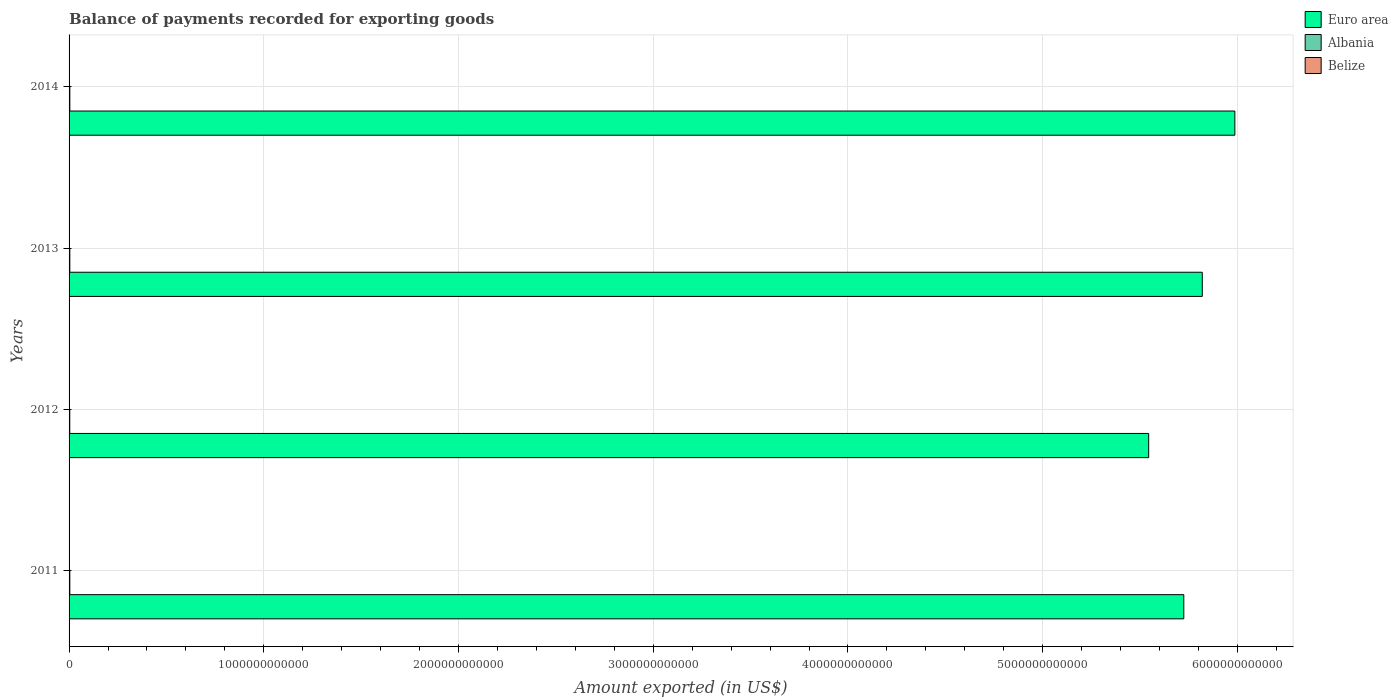How many different coloured bars are there?
Your response must be concise. 3. How many groups of bars are there?
Provide a succinct answer. 4. Are the number of bars per tick equal to the number of legend labels?
Give a very brief answer. Yes. Are the number of bars on each tick of the Y-axis equal?
Keep it short and to the point. Yes. How many bars are there on the 4th tick from the top?
Your response must be concise. 3. What is the label of the 1st group of bars from the top?
Your answer should be very brief. 2014. In how many cases, is the number of bars for a given year not equal to the number of legend labels?
Give a very brief answer. 0. What is the amount exported in Albania in 2014?
Ensure brevity in your answer.  3.92e+09. Across all years, what is the maximum amount exported in Euro area?
Provide a short and direct response. 5.99e+12. Across all years, what is the minimum amount exported in Albania?
Your response must be concise. 3.56e+09. What is the total amount exported in Euro area in the graph?
Your response must be concise. 2.31e+13. What is the difference between the amount exported in Albania in 2012 and that in 2013?
Your response must be concise. -2.87e+08. What is the difference between the amount exported in Albania in 2011 and the amount exported in Euro area in 2013?
Give a very brief answer. -5.82e+12. What is the average amount exported in Albania per year?
Offer a terse response. 3.78e+09. In the year 2012, what is the difference between the amount exported in Belize and amount exported in Euro area?
Your answer should be very brief. -5.54e+12. In how many years, is the amount exported in Albania greater than 1200000000000 US$?
Keep it short and to the point. 0. What is the ratio of the amount exported in Euro area in 2012 to that in 2013?
Ensure brevity in your answer.  0.95. Is the difference between the amount exported in Belize in 2011 and 2014 greater than the difference between the amount exported in Euro area in 2011 and 2014?
Ensure brevity in your answer.  Yes. What is the difference between the highest and the second highest amount exported in Euro area?
Your answer should be very brief. 1.67e+11. What is the difference between the highest and the lowest amount exported in Euro area?
Ensure brevity in your answer.  4.43e+11. In how many years, is the amount exported in Belize greater than the average amount exported in Belize taken over all years?
Provide a succinct answer. 3. What does the 2nd bar from the top in 2012 represents?
Provide a short and direct response. Albania. What does the 2nd bar from the bottom in 2012 represents?
Ensure brevity in your answer.  Albania. Are all the bars in the graph horizontal?
Make the answer very short. Yes. What is the difference between two consecutive major ticks on the X-axis?
Offer a terse response. 1.00e+12. Are the values on the major ticks of X-axis written in scientific E-notation?
Offer a very short reply. No. Does the graph contain any zero values?
Your response must be concise. No. Does the graph contain grids?
Offer a terse response. Yes. Where does the legend appear in the graph?
Your answer should be compact. Top right. How many legend labels are there?
Offer a very short reply. 3. How are the legend labels stacked?
Offer a very short reply. Vertical. What is the title of the graph?
Your answer should be very brief. Balance of payments recorded for exporting goods. Does "Channel Islands" appear as one of the legend labels in the graph?
Your answer should be very brief. No. What is the label or title of the X-axis?
Your answer should be very brief. Amount exported (in US$). What is the Amount exported (in US$) of Euro area in 2011?
Give a very brief answer. 5.72e+12. What is the Amount exported (in US$) of Albania in 2011?
Make the answer very short. 3.78e+09. What is the Amount exported (in US$) of Belize in 2011?
Give a very brief answer. 9.44e+08. What is the Amount exported (in US$) in Euro area in 2012?
Provide a succinct answer. 5.54e+12. What is the Amount exported (in US$) in Albania in 2012?
Give a very brief answer. 3.56e+09. What is the Amount exported (in US$) of Belize in 2012?
Offer a terse response. 1.03e+09. What is the Amount exported (in US$) of Euro area in 2013?
Your answer should be very brief. 5.82e+12. What is the Amount exported (in US$) of Albania in 2013?
Your answer should be compact. 3.84e+09. What is the Amount exported (in US$) in Belize in 2013?
Your response must be concise. 1.06e+09. What is the Amount exported (in US$) of Euro area in 2014?
Your response must be concise. 5.99e+12. What is the Amount exported (in US$) in Albania in 2014?
Provide a succinct answer. 3.92e+09. What is the Amount exported (in US$) in Belize in 2014?
Ensure brevity in your answer.  1.08e+09. Across all years, what is the maximum Amount exported (in US$) in Euro area?
Your response must be concise. 5.99e+12. Across all years, what is the maximum Amount exported (in US$) in Albania?
Give a very brief answer. 3.92e+09. Across all years, what is the maximum Amount exported (in US$) of Belize?
Offer a very short reply. 1.08e+09. Across all years, what is the minimum Amount exported (in US$) of Euro area?
Offer a very short reply. 5.54e+12. Across all years, what is the minimum Amount exported (in US$) of Albania?
Your response must be concise. 3.56e+09. Across all years, what is the minimum Amount exported (in US$) in Belize?
Provide a succinct answer. 9.44e+08. What is the total Amount exported (in US$) of Euro area in the graph?
Ensure brevity in your answer.  2.31e+13. What is the total Amount exported (in US$) of Albania in the graph?
Provide a short and direct response. 1.51e+1. What is the total Amount exported (in US$) of Belize in the graph?
Offer a very short reply. 4.12e+09. What is the difference between the Amount exported (in US$) in Euro area in 2011 and that in 2012?
Ensure brevity in your answer.  1.80e+11. What is the difference between the Amount exported (in US$) in Albania in 2011 and that in 2012?
Offer a very short reply. 2.19e+08. What is the difference between the Amount exported (in US$) in Belize in 2011 and that in 2012?
Your answer should be very brief. -9.06e+07. What is the difference between the Amount exported (in US$) of Euro area in 2011 and that in 2013?
Give a very brief answer. -9.49e+1. What is the difference between the Amount exported (in US$) in Albania in 2011 and that in 2013?
Ensure brevity in your answer.  -6.77e+07. What is the difference between the Amount exported (in US$) in Belize in 2011 and that in 2013?
Provide a short and direct response. -1.12e+08. What is the difference between the Amount exported (in US$) in Euro area in 2011 and that in 2014?
Keep it short and to the point. -2.62e+11. What is the difference between the Amount exported (in US$) of Albania in 2011 and that in 2014?
Your answer should be compact. -1.48e+08. What is the difference between the Amount exported (in US$) in Belize in 2011 and that in 2014?
Provide a short and direct response. -1.39e+08. What is the difference between the Amount exported (in US$) in Euro area in 2012 and that in 2013?
Offer a terse response. -2.75e+11. What is the difference between the Amount exported (in US$) of Albania in 2012 and that in 2013?
Ensure brevity in your answer.  -2.87e+08. What is the difference between the Amount exported (in US$) in Belize in 2012 and that in 2013?
Ensure brevity in your answer.  -2.17e+07. What is the difference between the Amount exported (in US$) of Euro area in 2012 and that in 2014?
Your answer should be very brief. -4.43e+11. What is the difference between the Amount exported (in US$) of Albania in 2012 and that in 2014?
Make the answer very short. -3.67e+08. What is the difference between the Amount exported (in US$) in Belize in 2012 and that in 2014?
Ensure brevity in your answer.  -4.86e+07. What is the difference between the Amount exported (in US$) in Euro area in 2013 and that in 2014?
Provide a succinct answer. -1.67e+11. What is the difference between the Amount exported (in US$) of Albania in 2013 and that in 2014?
Give a very brief answer. -8.00e+07. What is the difference between the Amount exported (in US$) of Belize in 2013 and that in 2014?
Your answer should be very brief. -2.69e+07. What is the difference between the Amount exported (in US$) in Euro area in 2011 and the Amount exported (in US$) in Albania in 2012?
Your answer should be compact. 5.72e+12. What is the difference between the Amount exported (in US$) in Euro area in 2011 and the Amount exported (in US$) in Belize in 2012?
Provide a short and direct response. 5.72e+12. What is the difference between the Amount exported (in US$) in Albania in 2011 and the Amount exported (in US$) in Belize in 2012?
Your response must be concise. 2.74e+09. What is the difference between the Amount exported (in US$) of Euro area in 2011 and the Amount exported (in US$) of Albania in 2013?
Your response must be concise. 5.72e+12. What is the difference between the Amount exported (in US$) in Euro area in 2011 and the Amount exported (in US$) in Belize in 2013?
Keep it short and to the point. 5.72e+12. What is the difference between the Amount exported (in US$) of Albania in 2011 and the Amount exported (in US$) of Belize in 2013?
Your answer should be very brief. 2.72e+09. What is the difference between the Amount exported (in US$) in Euro area in 2011 and the Amount exported (in US$) in Albania in 2014?
Offer a terse response. 5.72e+12. What is the difference between the Amount exported (in US$) of Euro area in 2011 and the Amount exported (in US$) of Belize in 2014?
Your response must be concise. 5.72e+12. What is the difference between the Amount exported (in US$) in Albania in 2011 and the Amount exported (in US$) in Belize in 2014?
Offer a terse response. 2.69e+09. What is the difference between the Amount exported (in US$) of Euro area in 2012 and the Amount exported (in US$) of Albania in 2013?
Ensure brevity in your answer.  5.54e+12. What is the difference between the Amount exported (in US$) of Euro area in 2012 and the Amount exported (in US$) of Belize in 2013?
Your answer should be very brief. 5.54e+12. What is the difference between the Amount exported (in US$) in Albania in 2012 and the Amount exported (in US$) in Belize in 2013?
Your response must be concise. 2.50e+09. What is the difference between the Amount exported (in US$) in Euro area in 2012 and the Amount exported (in US$) in Albania in 2014?
Give a very brief answer. 5.54e+12. What is the difference between the Amount exported (in US$) of Euro area in 2012 and the Amount exported (in US$) of Belize in 2014?
Make the answer very short. 5.54e+12. What is the difference between the Amount exported (in US$) of Albania in 2012 and the Amount exported (in US$) of Belize in 2014?
Your answer should be very brief. 2.47e+09. What is the difference between the Amount exported (in US$) of Euro area in 2013 and the Amount exported (in US$) of Albania in 2014?
Provide a short and direct response. 5.82e+12. What is the difference between the Amount exported (in US$) of Euro area in 2013 and the Amount exported (in US$) of Belize in 2014?
Provide a short and direct response. 5.82e+12. What is the difference between the Amount exported (in US$) in Albania in 2013 and the Amount exported (in US$) in Belize in 2014?
Provide a succinct answer. 2.76e+09. What is the average Amount exported (in US$) of Euro area per year?
Your response must be concise. 5.77e+12. What is the average Amount exported (in US$) in Albania per year?
Make the answer very short. 3.78e+09. What is the average Amount exported (in US$) in Belize per year?
Your answer should be very brief. 1.03e+09. In the year 2011, what is the difference between the Amount exported (in US$) in Euro area and Amount exported (in US$) in Albania?
Your answer should be very brief. 5.72e+12. In the year 2011, what is the difference between the Amount exported (in US$) of Euro area and Amount exported (in US$) of Belize?
Your response must be concise. 5.72e+12. In the year 2011, what is the difference between the Amount exported (in US$) in Albania and Amount exported (in US$) in Belize?
Keep it short and to the point. 2.83e+09. In the year 2012, what is the difference between the Amount exported (in US$) in Euro area and Amount exported (in US$) in Albania?
Your answer should be very brief. 5.54e+12. In the year 2012, what is the difference between the Amount exported (in US$) of Euro area and Amount exported (in US$) of Belize?
Your answer should be very brief. 5.54e+12. In the year 2012, what is the difference between the Amount exported (in US$) in Albania and Amount exported (in US$) in Belize?
Your answer should be compact. 2.52e+09. In the year 2013, what is the difference between the Amount exported (in US$) of Euro area and Amount exported (in US$) of Albania?
Your response must be concise. 5.82e+12. In the year 2013, what is the difference between the Amount exported (in US$) in Euro area and Amount exported (in US$) in Belize?
Give a very brief answer. 5.82e+12. In the year 2013, what is the difference between the Amount exported (in US$) in Albania and Amount exported (in US$) in Belize?
Ensure brevity in your answer.  2.79e+09. In the year 2014, what is the difference between the Amount exported (in US$) in Euro area and Amount exported (in US$) in Albania?
Ensure brevity in your answer.  5.98e+12. In the year 2014, what is the difference between the Amount exported (in US$) of Euro area and Amount exported (in US$) of Belize?
Your response must be concise. 5.99e+12. In the year 2014, what is the difference between the Amount exported (in US$) of Albania and Amount exported (in US$) of Belize?
Ensure brevity in your answer.  2.84e+09. What is the ratio of the Amount exported (in US$) in Euro area in 2011 to that in 2012?
Keep it short and to the point. 1.03. What is the ratio of the Amount exported (in US$) of Albania in 2011 to that in 2012?
Ensure brevity in your answer.  1.06. What is the ratio of the Amount exported (in US$) of Belize in 2011 to that in 2012?
Make the answer very short. 0.91. What is the ratio of the Amount exported (in US$) in Euro area in 2011 to that in 2013?
Provide a succinct answer. 0.98. What is the ratio of the Amount exported (in US$) of Albania in 2011 to that in 2013?
Give a very brief answer. 0.98. What is the ratio of the Amount exported (in US$) of Belize in 2011 to that in 2013?
Provide a succinct answer. 0.89. What is the ratio of the Amount exported (in US$) of Euro area in 2011 to that in 2014?
Give a very brief answer. 0.96. What is the ratio of the Amount exported (in US$) of Albania in 2011 to that in 2014?
Keep it short and to the point. 0.96. What is the ratio of the Amount exported (in US$) of Belize in 2011 to that in 2014?
Provide a succinct answer. 0.87. What is the ratio of the Amount exported (in US$) of Euro area in 2012 to that in 2013?
Ensure brevity in your answer.  0.95. What is the ratio of the Amount exported (in US$) in Albania in 2012 to that in 2013?
Provide a short and direct response. 0.93. What is the ratio of the Amount exported (in US$) of Belize in 2012 to that in 2013?
Provide a short and direct response. 0.98. What is the ratio of the Amount exported (in US$) of Euro area in 2012 to that in 2014?
Your response must be concise. 0.93. What is the ratio of the Amount exported (in US$) of Albania in 2012 to that in 2014?
Make the answer very short. 0.91. What is the ratio of the Amount exported (in US$) of Belize in 2012 to that in 2014?
Keep it short and to the point. 0.96. What is the ratio of the Amount exported (in US$) in Euro area in 2013 to that in 2014?
Provide a short and direct response. 0.97. What is the ratio of the Amount exported (in US$) of Albania in 2013 to that in 2014?
Provide a short and direct response. 0.98. What is the ratio of the Amount exported (in US$) of Belize in 2013 to that in 2014?
Ensure brevity in your answer.  0.98. What is the difference between the highest and the second highest Amount exported (in US$) in Euro area?
Your response must be concise. 1.67e+11. What is the difference between the highest and the second highest Amount exported (in US$) of Albania?
Provide a short and direct response. 8.00e+07. What is the difference between the highest and the second highest Amount exported (in US$) of Belize?
Your response must be concise. 2.69e+07. What is the difference between the highest and the lowest Amount exported (in US$) in Euro area?
Your answer should be very brief. 4.43e+11. What is the difference between the highest and the lowest Amount exported (in US$) of Albania?
Your answer should be very brief. 3.67e+08. What is the difference between the highest and the lowest Amount exported (in US$) in Belize?
Offer a very short reply. 1.39e+08. 